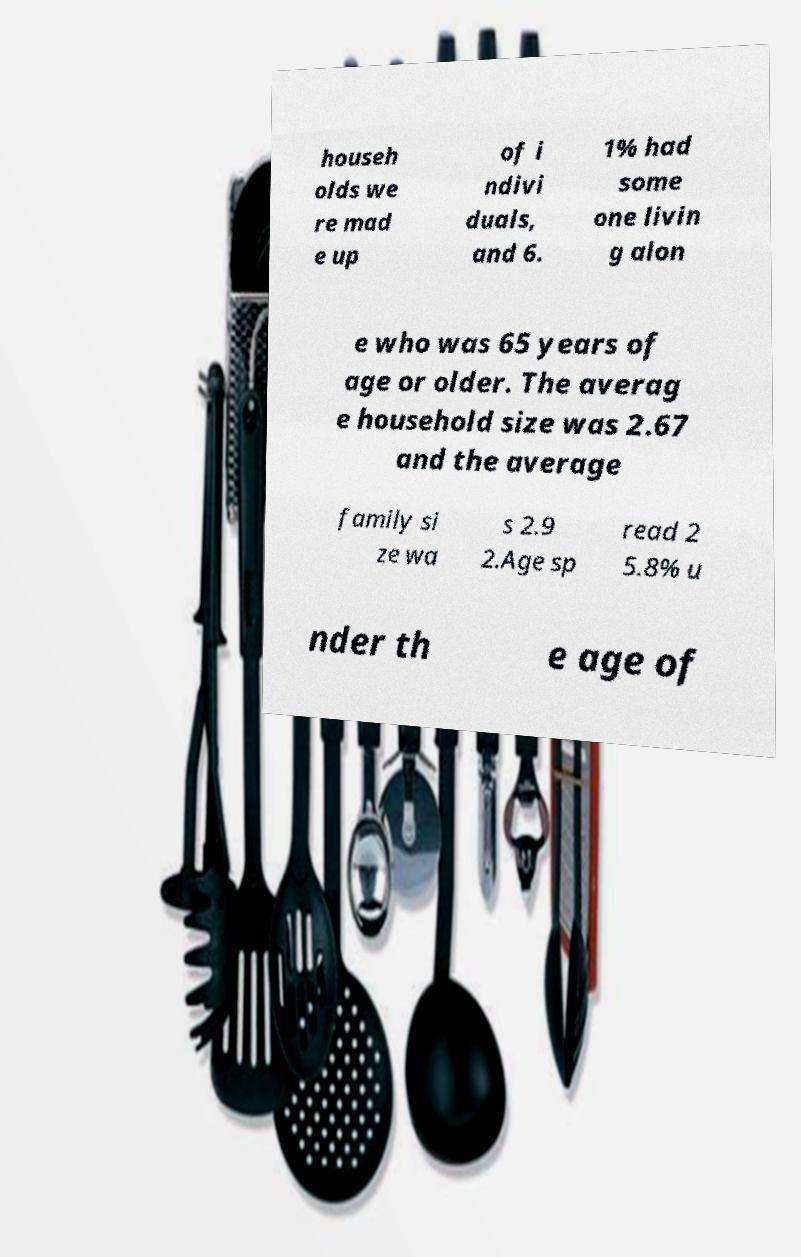I need the written content from this picture converted into text. Can you do that? househ olds we re mad e up of i ndivi duals, and 6. 1% had some one livin g alon e who was 65 years of age or older. The averag e household size was 2.67 and the average family si ze wa s 2.9 2.Age sp read 2 5.8% u nder th e age of 